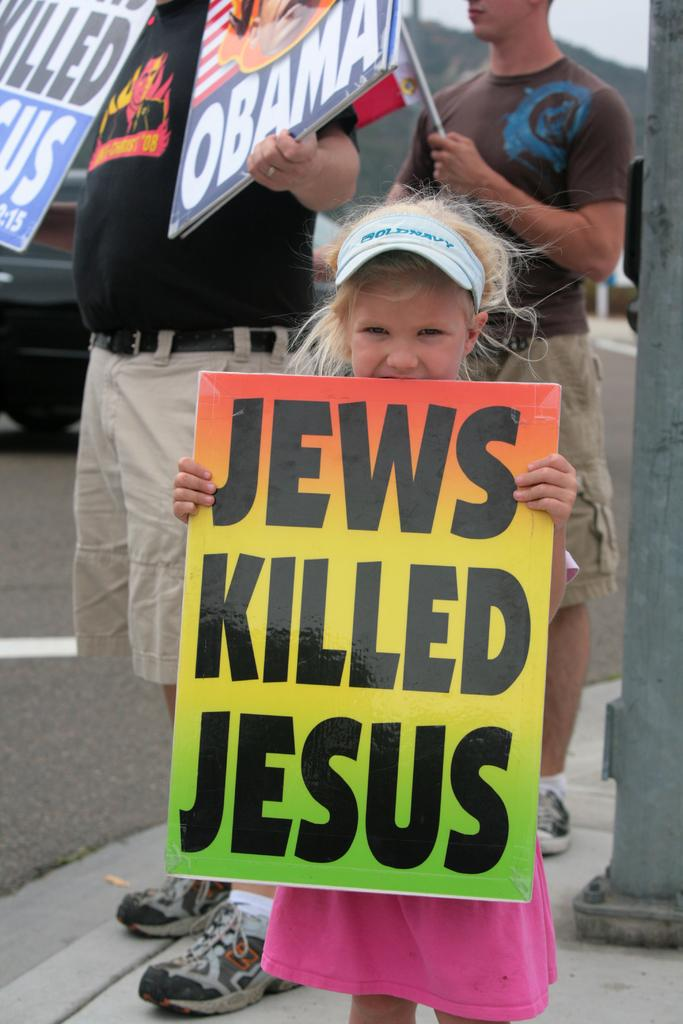How many people are in the image? There are three people in the image: a girl and two men. What are the people in the image doing? The girl and men are standing. What are the people wearing in the image? They are wearing clothes and shoes. What can be seen on the walls in the image? There are posters in the image. What is on the road in the image? There is a vehicle on the road. What is present near the road in the image? There is a pole in the image. What is visible in the background of the image? The sky is visible in the image. What language are the people speaking in the image? There is no indication of the language being spoken in the image. Is there a fire visible in the image? No, there is no fire present in the image. Is there snow on the ground in the image? No, there is no snow visible in the image. 